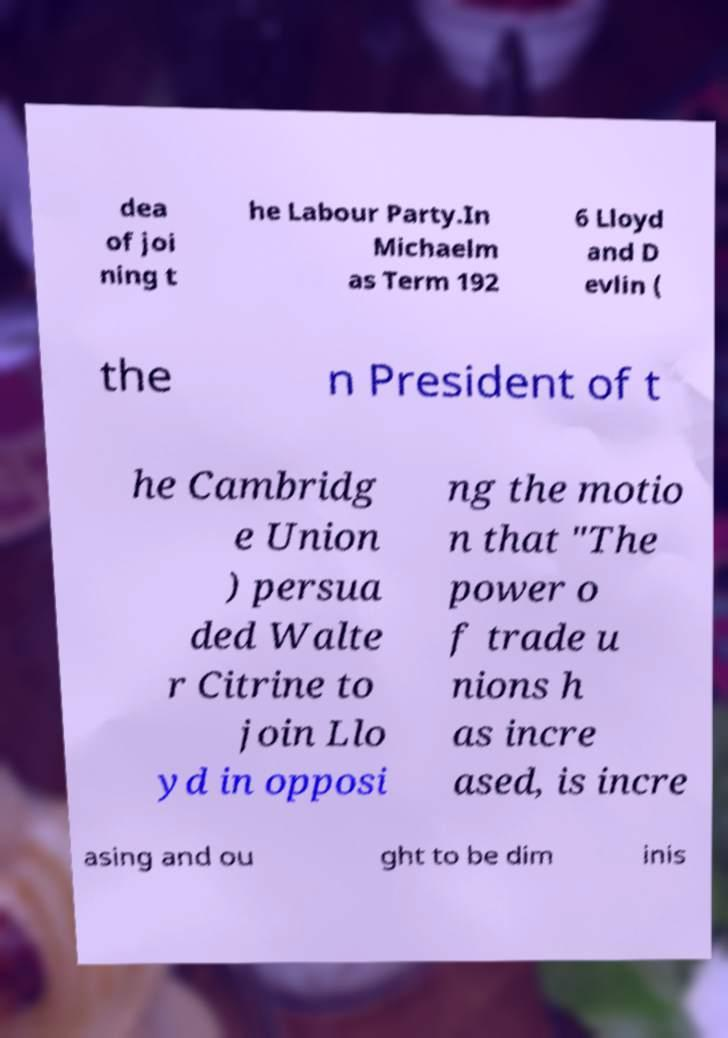Please identify and transcribe the text found in this image. dea of joi ning t he Labour Party.In Michaelm as Term 192 6 Lloyd and D evlin ( the n President of t he Cambridg e Union ) persua ded Walte r Citrine to join Llo yd in opposi ng the motio n that "The power o f trade u nions h as incre ased, is incre asing and ou ght to be dim inis 